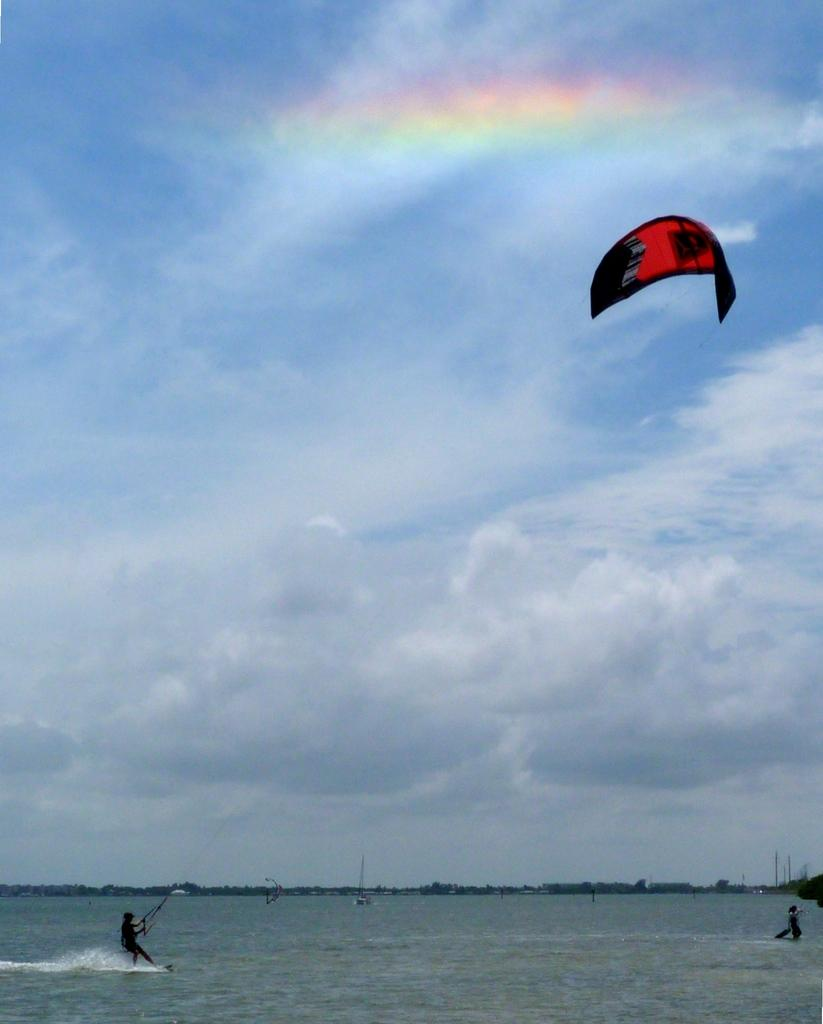What activity is the woman in the image participating in? The woman is parasailing in the image. Where is the woman located in the image? The woman is on the water in the image. What structures can be seen in the image? There are poles visible in the image. What natural phenomenon is present in the image? There is a rainbow in the image. How would you describe the sky in the image? The sky appears cloudy in the image. What type of arm is the woman using to hold the celery in the image? There is no celery or arm present in the image; the woman is parasailing and holding onto a parasail. 